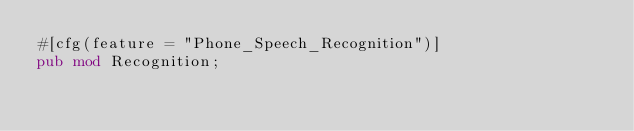<code> <loc_0><loc_0><loc_500><loc_500><_Rust_>#[cfg(feature = "Phone_Speech_Recognition")]
pub mod Recognition;
</code> 